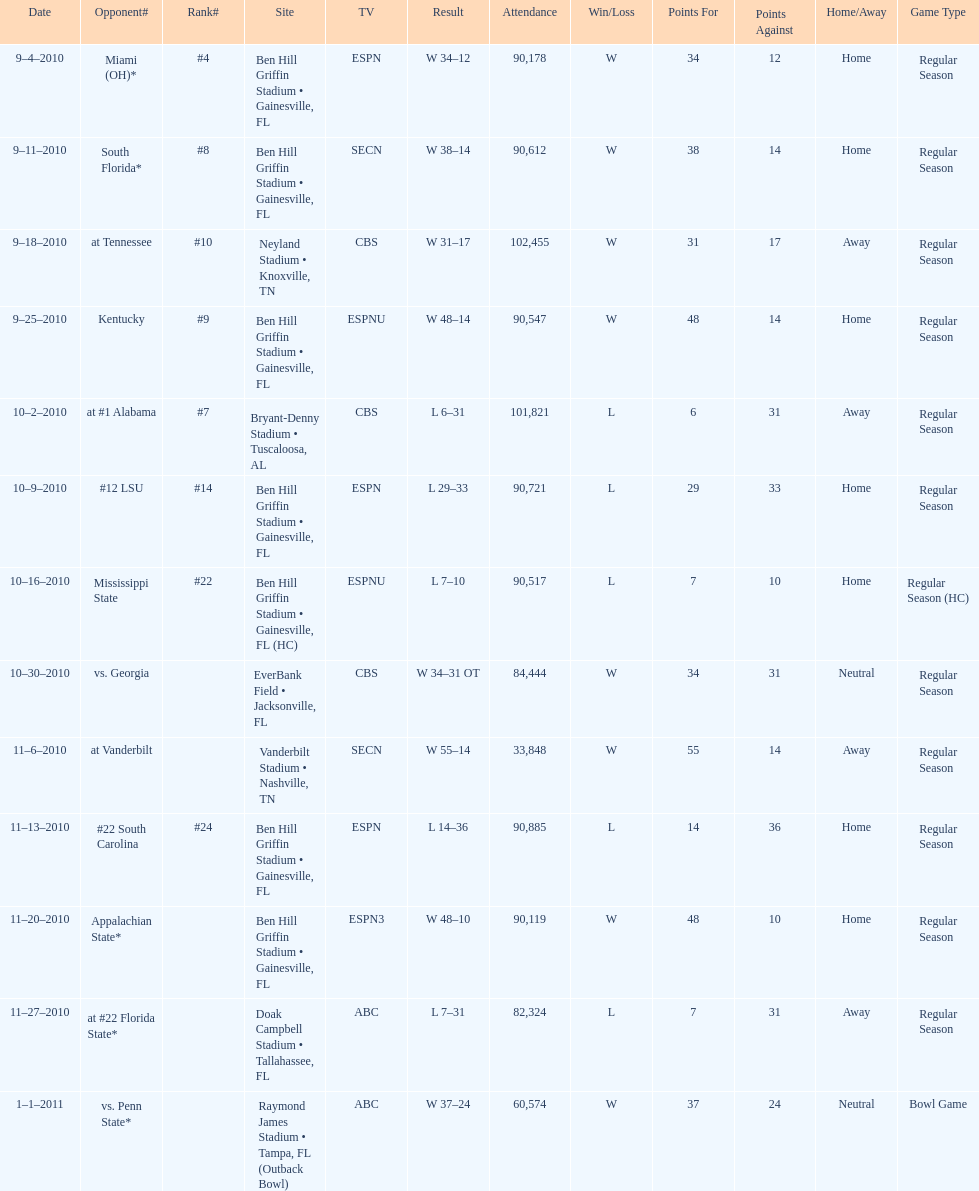What is the number of games played in teh 2010-2011 season 13. 